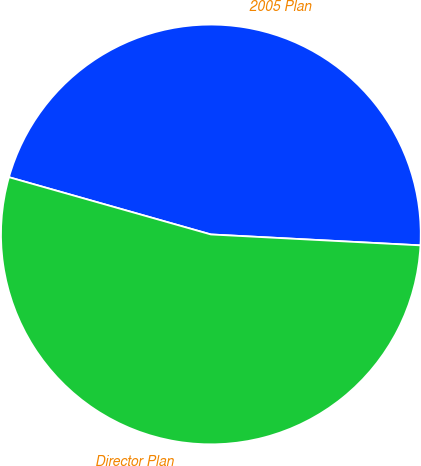<chart> <loc_0><loc_0><loc_500><loc_500><pie_chart><fcel>2005 Plan<fcel>Director Plan<nl><fcel>46.43%<fcel>53.57%<nl></chart> 